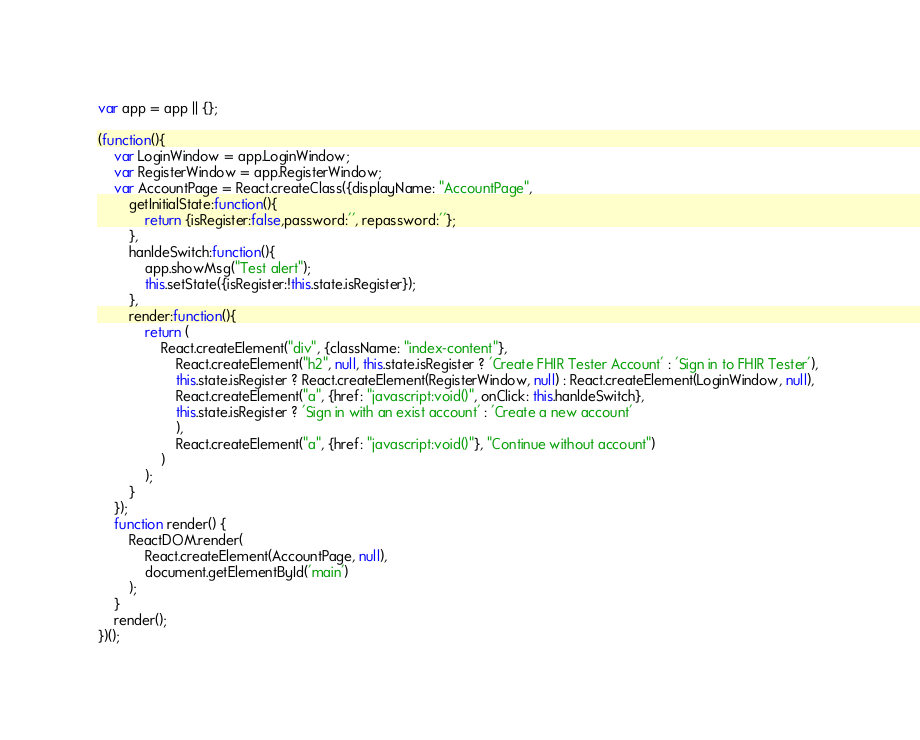<code> <loc_0><loc_0><loc_500><loc_500><_JavaScript_>var app = app || {};

(function(){
    var LoginWindow = app.LoginWindow;
    var RegisterWindow = app.RegisterWindow;
    var AccountPage = React.createClass({displayName: "AccountPage",
        getInitialState:function(){
            return {isRegister:false,password:'', repassword:''};
        },
        hanldeSwitch:function(){
            app.showMsg("Test alert");
            this.setState({isRegister:!this.state.isRegister});
        },
        render:function(){
            return (
                React.createElement("div", {className: "index-content"}, 
                    React.createElement("h2", null, this.state.isRegister ? 'Create FHIR Tester Account' : 'Sign in to FHIR Tester'), 
                    this.state.isRegister ? React.createElement(RegisterWindow, null) : React.createElement(LoginWindow, null), 
                    React.createElement("a", {href: "javascript:void()", onClick: this.hanldeSwitch}, 
                    this.state.isRegister ? 'Sign in with an exist account' : 'Create a new account'
                    ), 
                    React.createElement("a", {href: "javascript:void()"}, "Continue without account")
                )
            );
        }
    });
    function render() {
        ReactDOM.render( 
            React.createElement(AccountPage, null),
            document.getElementById('main')
        );
    }
    render();
})();</code> 